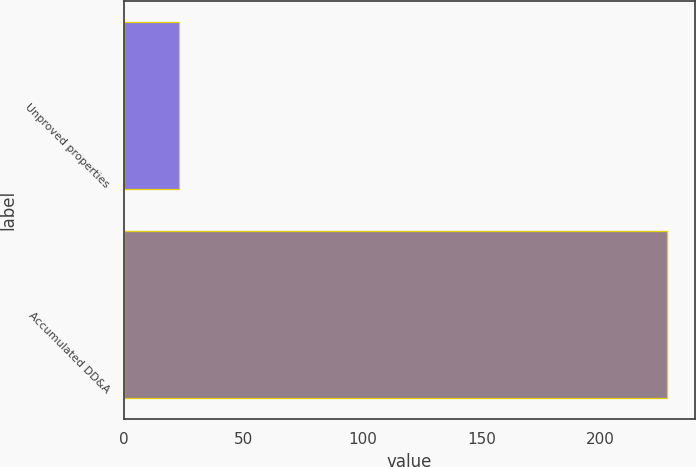<chart> <loc_0><loc_0><loc_500><loc_500><bar_chart><fcel>Unproved properties<fcel>Accumulated DD&A<nl><fcel>23<fcel>228<nl></chart> 